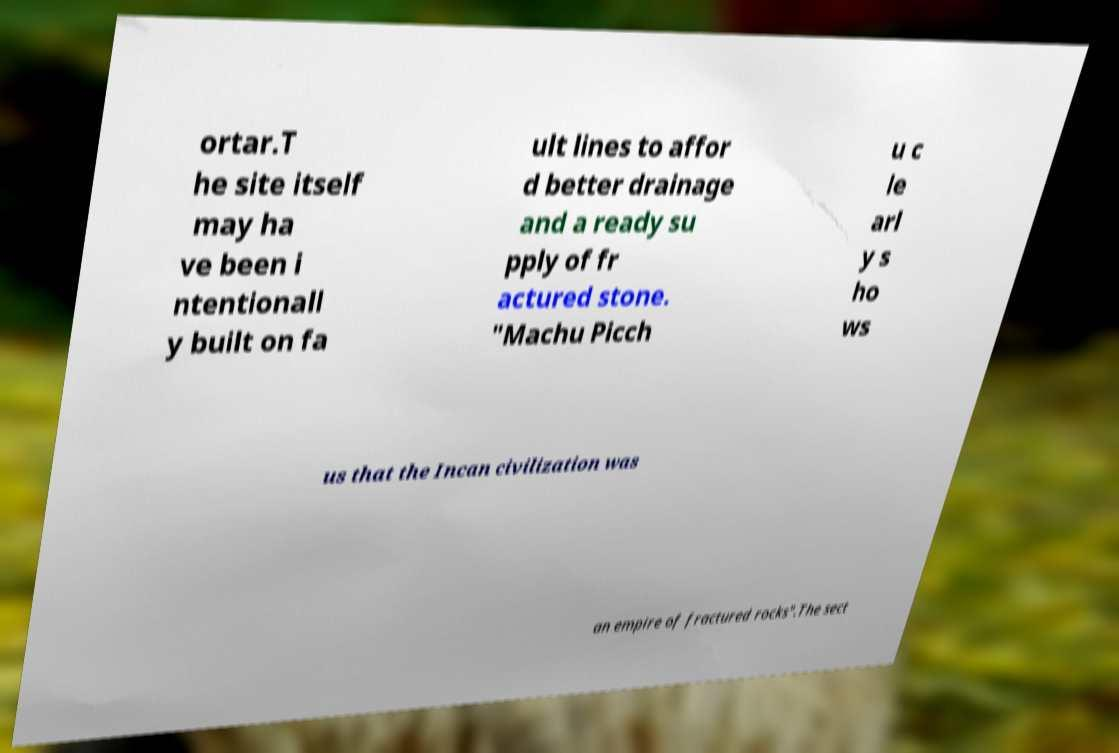I need the written content from this picture converted into text. Can you do that? ortar.T he site itself may ha ve been i ntentionall y built on fa ult lines to affor d better drainage and a ready su pply of fr actured stone. "Machu Picch u c le arl y s ho ws us that the Incan civilization was an empire of fractured rocks".The sect 